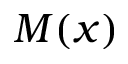<formula> <loc_0><loc_0><loc_500><loc_500>M ( x )</formula> 